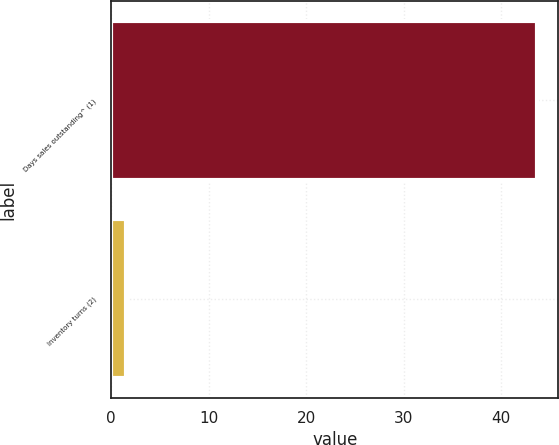Convert chart. <chart><loc_0><loc_0><loc_500><loc_500><bar_chart><fcel>Days sales outstanding^ (1)<fcel>Inventory turns (2)<nl><fcel>43.7<fcel>1.5<nl></chart> 